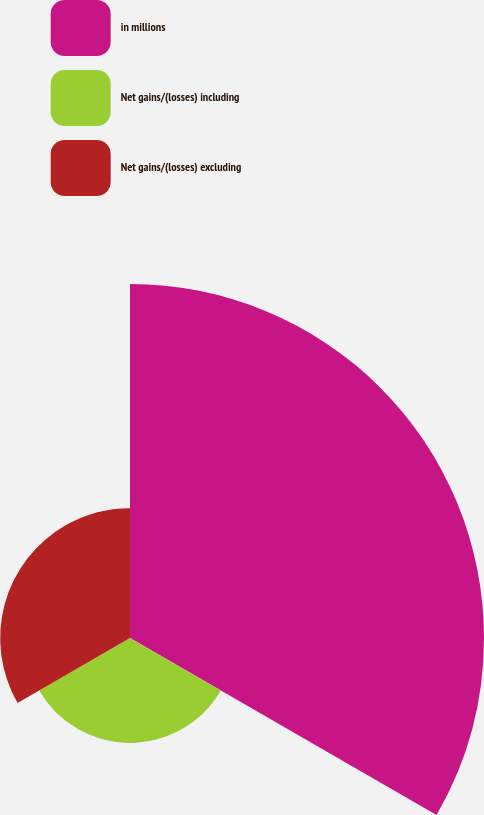Convert chart. <chart><loc_0><loc_0><loc_500><loc_500><pie_chart><fcel>in millions<fcel>Net gains/(losses) including<fcel>Net gains/(losses) excluding<nl><fcel>60.13%<fcel>17.82%<fcel>22.05%<nl></chart> 